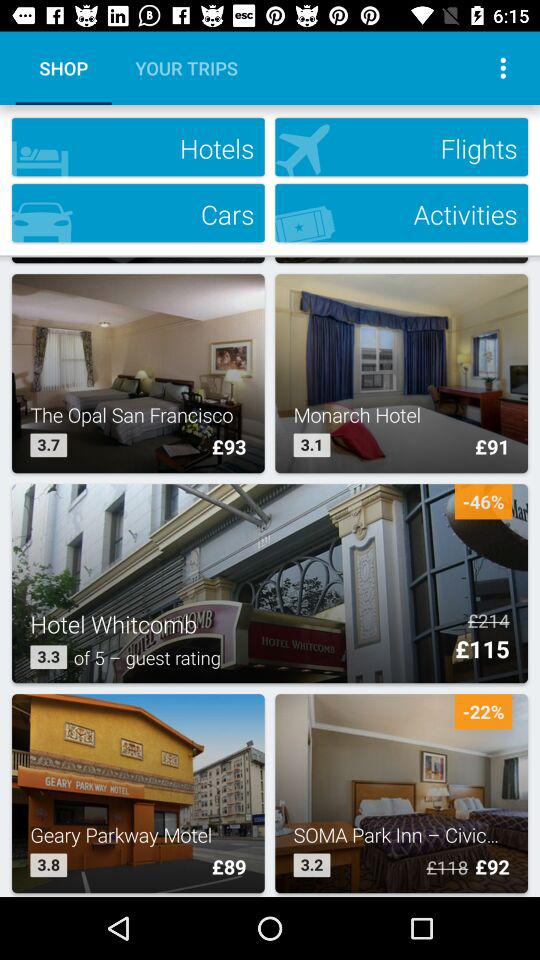What is the price of a room in "Hotel Whitcomb" before the discount? The price before the discount is £214. 